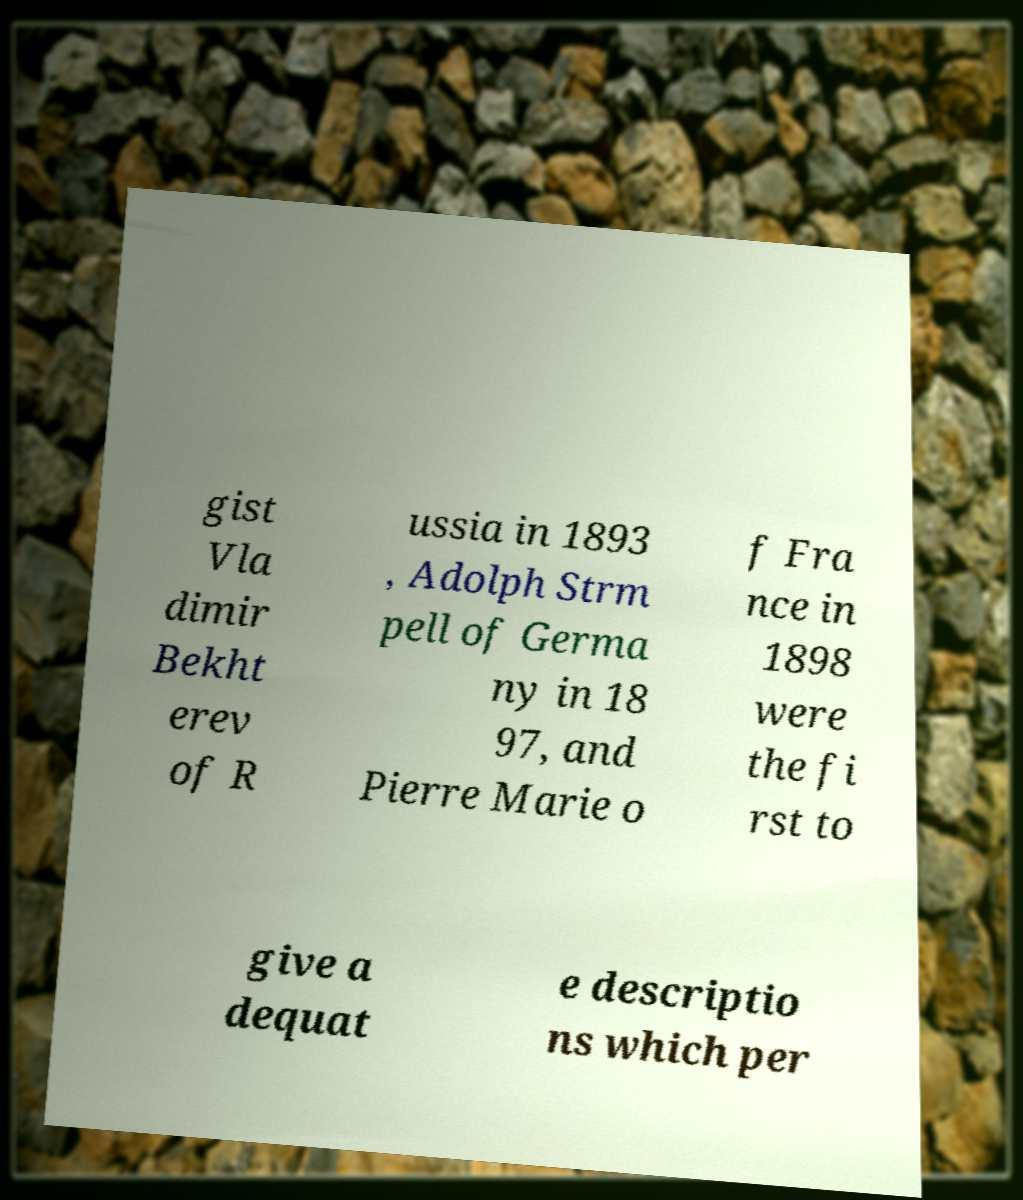Can you accurately transcribe the text from the provided image for me? gist Vla dimir Bekht erev of R ussia in 1893 , Adolph Strm pell of Germa ny in 18 97, and Pierre Marie o f Fra nce in 1898 were the fi rst to give a dequat e descriptio ns which per 